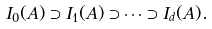Convert formula to latex. <formula><loc_0><loc_0><loc_500><loc_500>I _ { 0 } ( A ) \supset I _ { 1 } ( A ) \supset \cdots \supset I _ { d } ( A ) .</formula> 